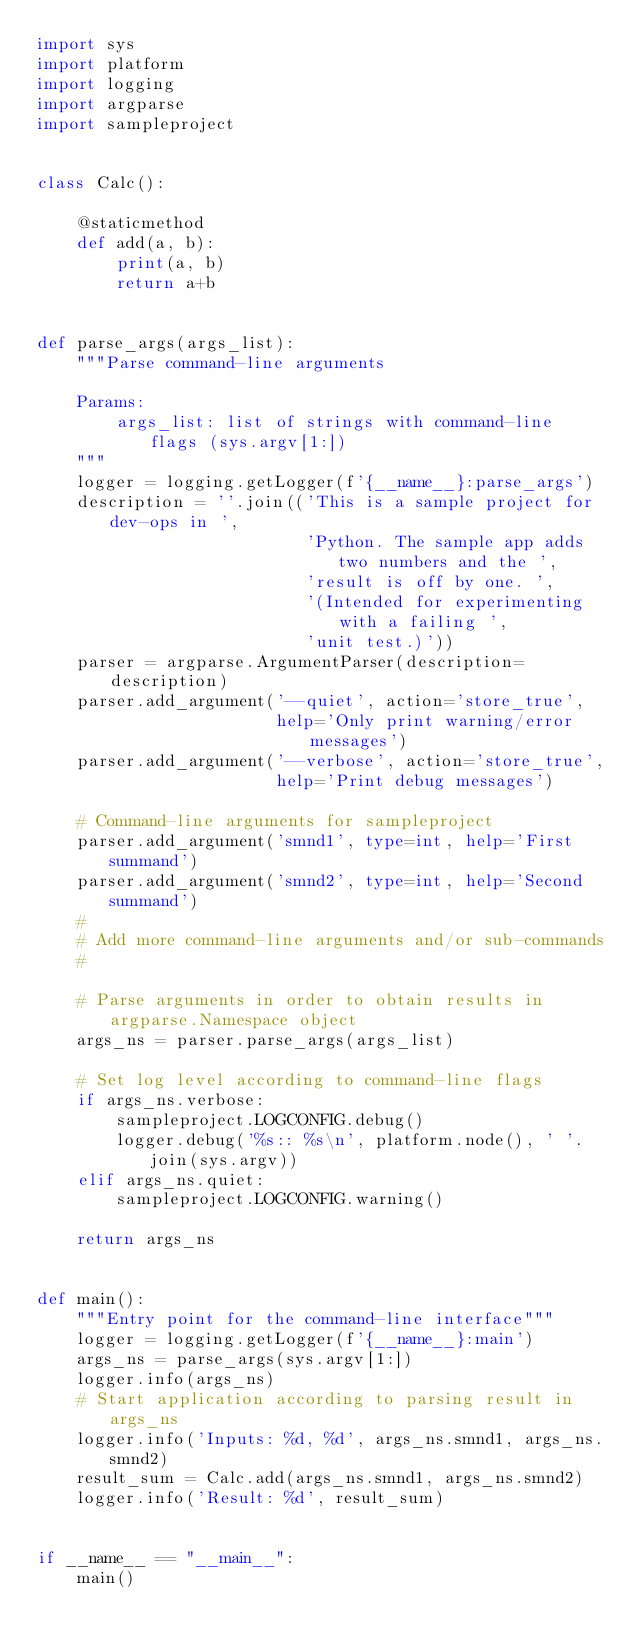Convert code to text. <code><loc_0><loc_0><loc_500><loc_500><_Python_>import sys
import platform
import logging
import argparse
import sampleproject


class Calc():

    @staticmethod
    def add(a, b):
        print(a, b)
        return a+b


def parse_args(args_list):
    """Parse command-line arguments

    Params:
        args_list: list of strings with command-line flags (sys.argv[1:])
    """
    logger = logging.getLogger(f'{__name__}:parse_args')
    description = ''.join(('This is a sample project for dev-ops in ',
                           'Python. The sample app adds two numbers and the ',
                           'result is off by one. ',
                           '(Intended for experimenting with a failing ',
                           'unit test.)'))
    parser = argparse.ArgumentParser(description=description)
    parser.add_argument('--quiet', action='store_true',
                        help='Only print warning/error messages')
    parser.add_argument('--verbose', action='store_true',
                        help='Print debug messages')

    # Command-line arguments for sampleproject
    parser.add_argument('smnd1', type=int, help='First summand')
    parser.add_argument('smnd2', type=int, help='Second summand')
    #
    # Add more command-line arguments and/or sub-commands
    #

    # Parse arguments in order to obtain results in argparse.Namespace object
    args_ns = parser.parse_args(args_list)

    # Set log level according to command-line flags
    if args_ns.verbose:
        sampleproject.LOGCONFIG.debug()
        logger.debug('%s:: %s\n', platform.node(), ' '.join(sys.argv))
    elif args_ns.quiet:
        sampleproject.LOGCONFIG.warning()

    return args_ns


def main():
    """Entry point for the command-line interface"""
    logger = logging.getLogger(f'{__name__}:main')
    args_ns = parse_args(sys.argv[1:])
    logger.info(args_ns)
    # Start application according to parsing result in args_ns
    logger.info('Inputs: %d, %d', args_ns.smnd1, args_ns.smnd2)
    result_sum = Calc.add(args_ns.smnd1, args_ns.smnd2)
    logger.info('Result: %d', result_sum)


if __name__ == "__main__":
    main()
</code> 